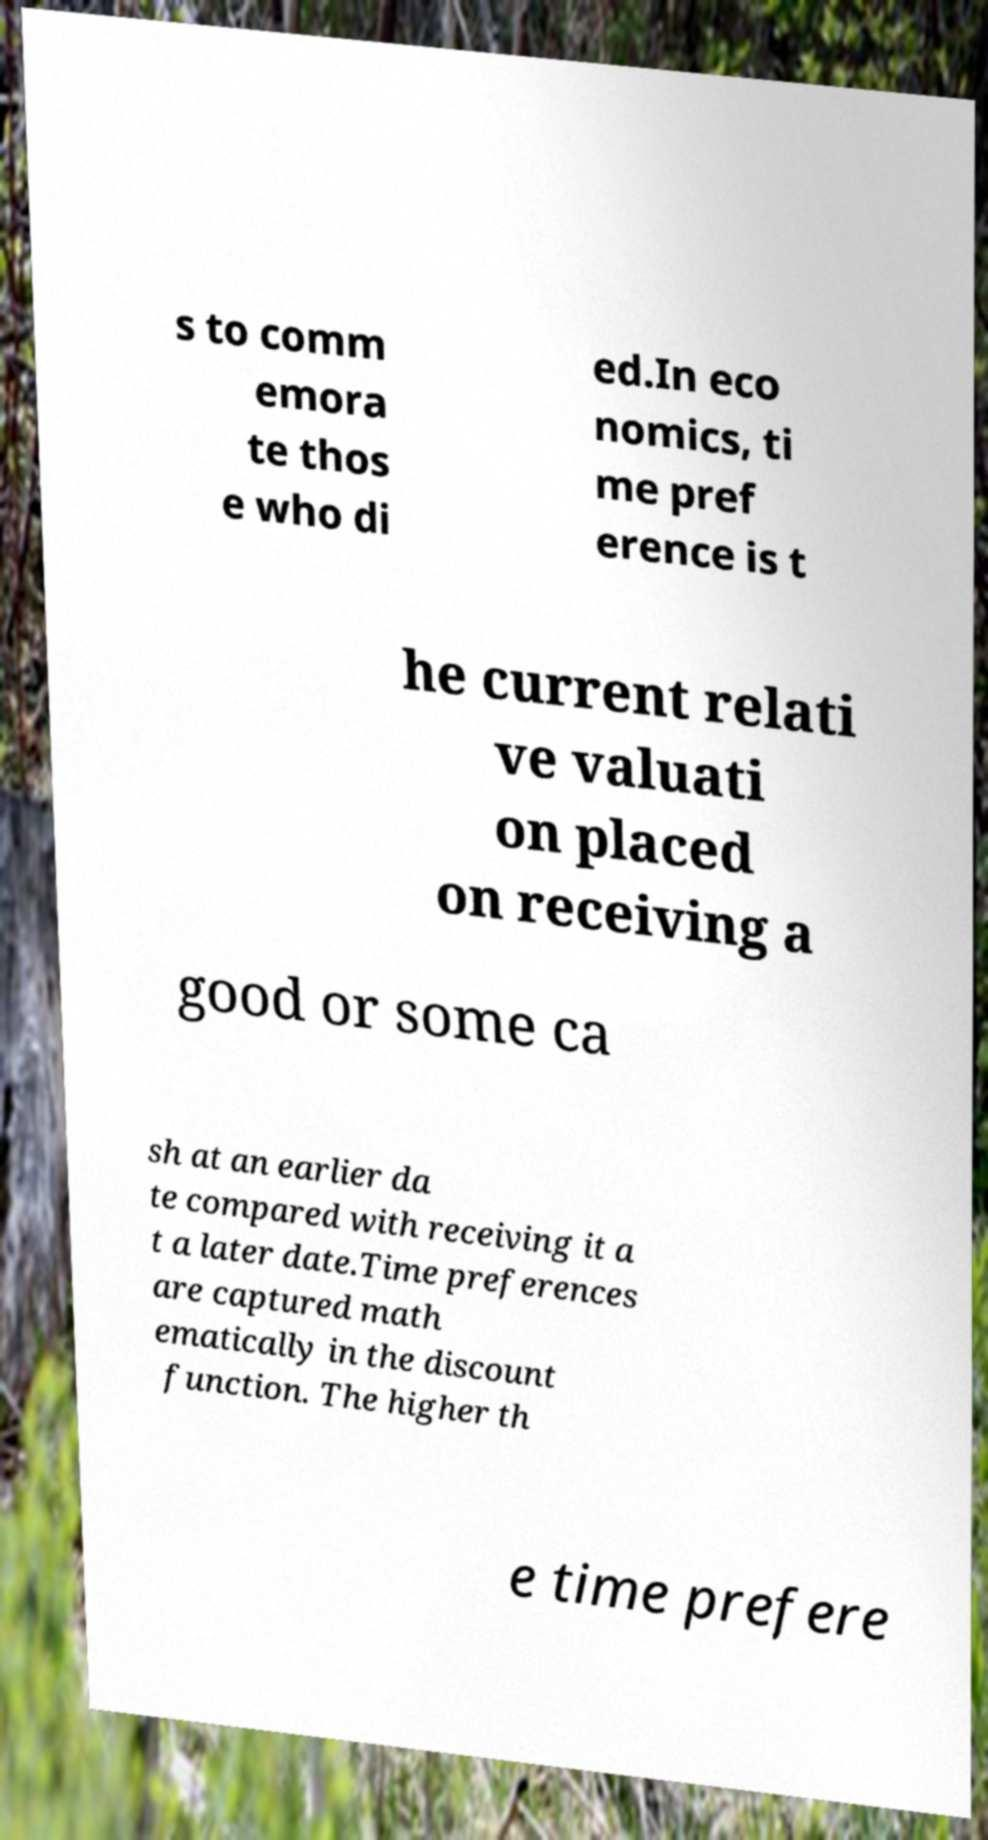Please identify and transcribe the text found in this image. s to comm emora te thos e who di ed.In eco nomics, ti me pref erence is t he current relati ve valuati on placed on receiving a good or some ca sh at an earlier da te compared with receiving it a t a later date.Time preferences are captured math ematically in the discount function. The higher th e time prefere 